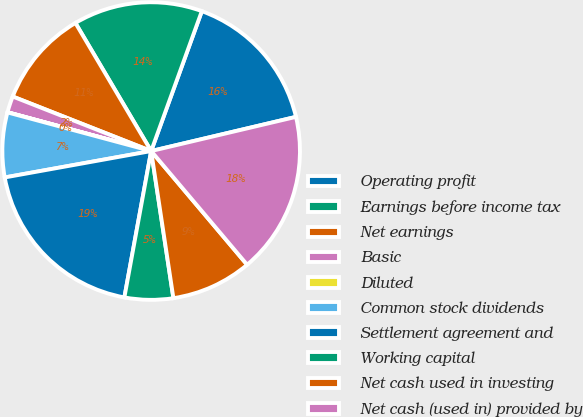<chart> <loc_0><loc_0><loc_500><loc_500><pie_chart><fcel>Operating profit<fcel>Earnings before income tax<fcel>Net earnings<fcel>Basic<fcel>Diluted<fcel>Common stock dividends<fcel>Settlement agreement and<fcel>Working capital<fcel>Net cash used in investing<fcel>Net cash (used in) provided by<nl><fcel>15.78%<fcel>14.03%<fcel>10.53%<fcel>1.77%<fcel>0.02%<fcel>7.02%<fcel>19.28%<fcel>5.27%<fcel>8.77%<fcel>17.53%<nl></chart> 